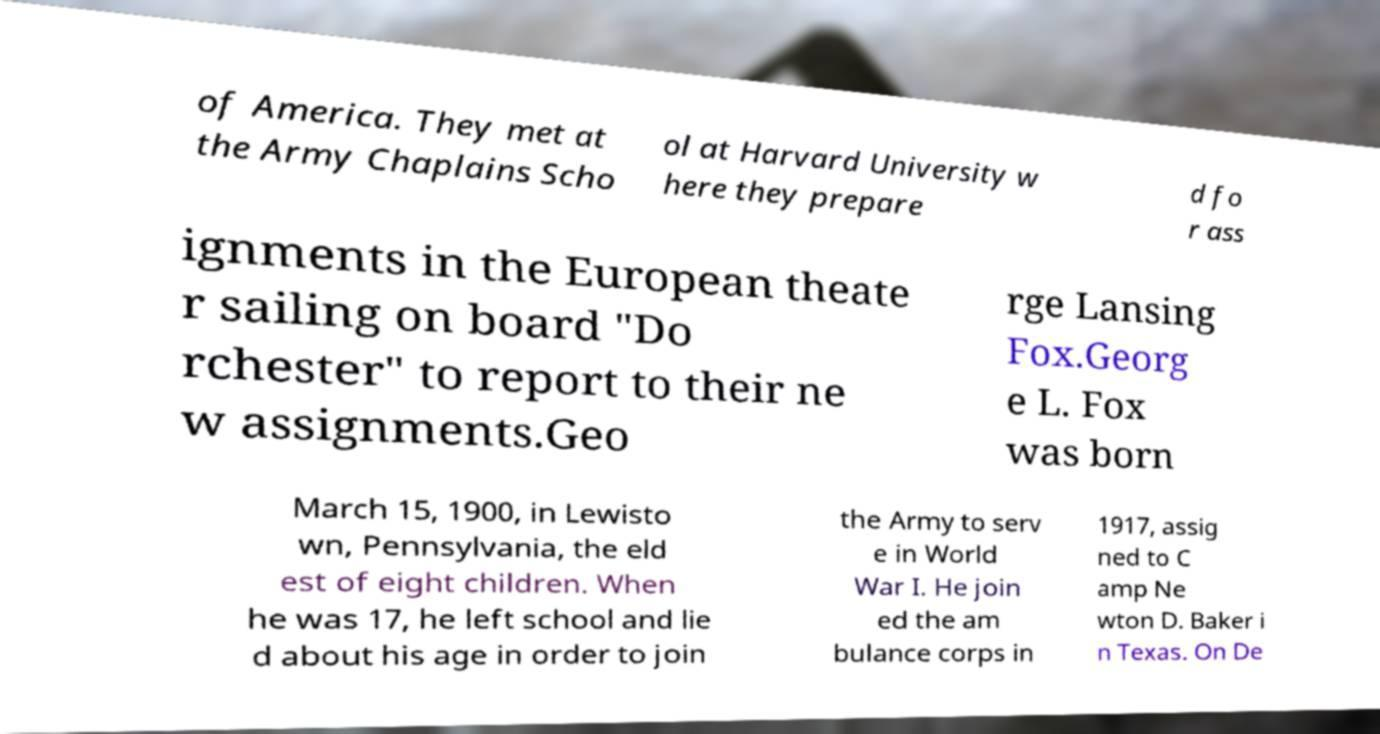For documentation purposes, I need the text within this image transcribed. Could you provide that? of America. They met at the Army Chaplains Scho ol at Harvard University w here they prepare d fo r ass ignments in the European theate r sailing on board "Do rchester" to report to their ne w assignments.Geo rge Lansing Fox.Georg e L. Fox was born March 15, 1900, in Lewisto wn, Pennsylvania, the eld est of eight children. When he was 17, he left school and lie d about his age in order to join the Army to serv e in World War I. He join ed the am bulance corps in 1917, assig ned to C amp Ne wton D. Baker i n Texas. On De 